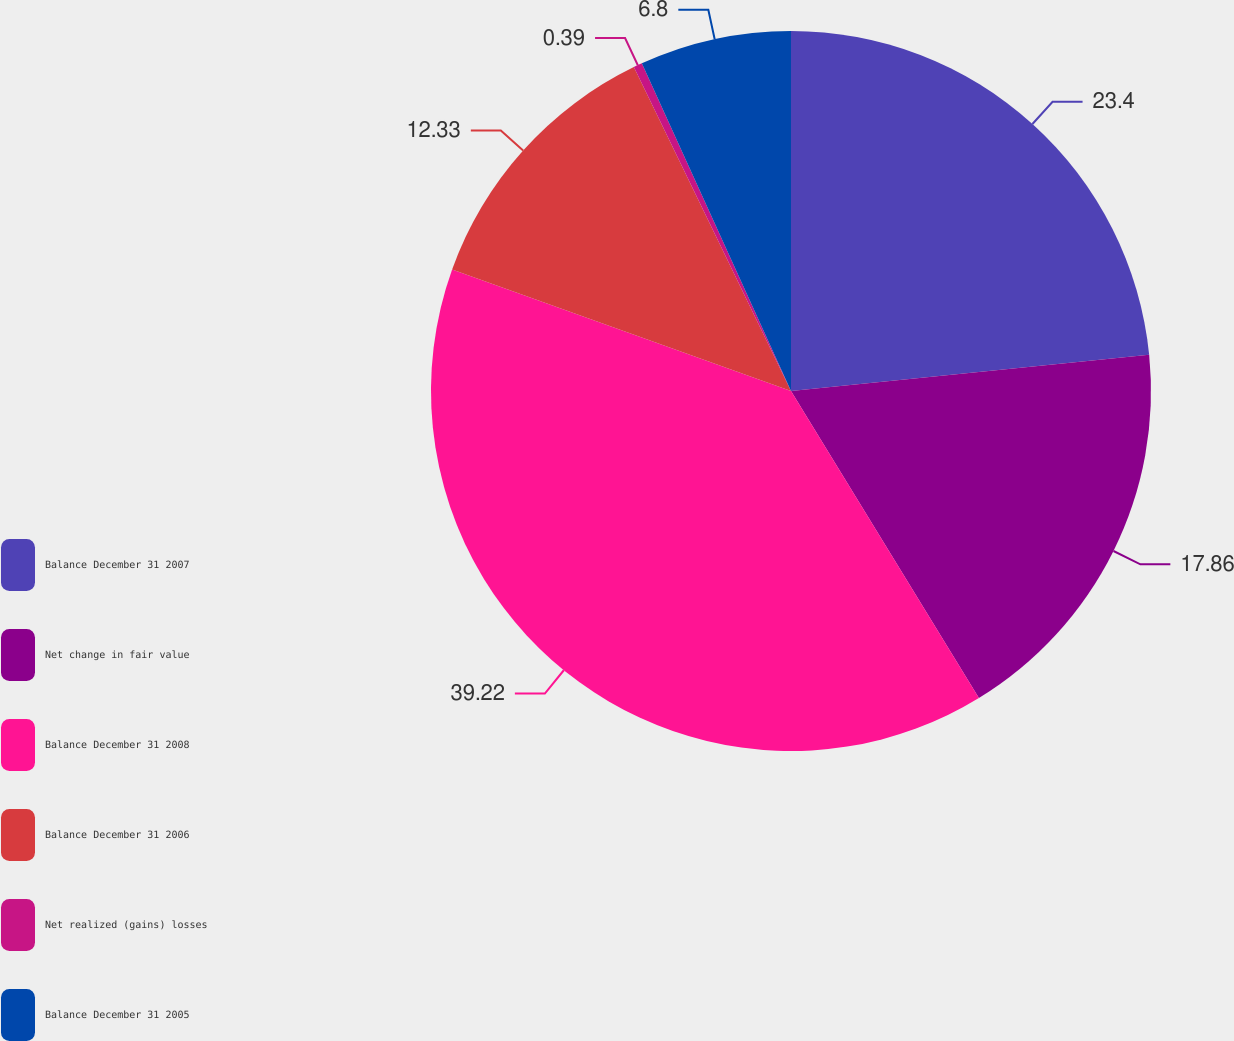Convert chart. <chart><loc_0><loc_0><loc_500><loc_500><pie_chart><fcel>Balance December 31 2007<fcel>Net change in fair value<fcel>Balance December 31 2008<fcel>Balance December 31 2006<fcel>Net realized (gains) losses<fcel>Balance December 31 2005<nl><fcel>23.4%<fcel>17.86%<fcel>39.22%<fcel>12.33%<fcel>0.39%<fcel>6.8%<nl></chart> 